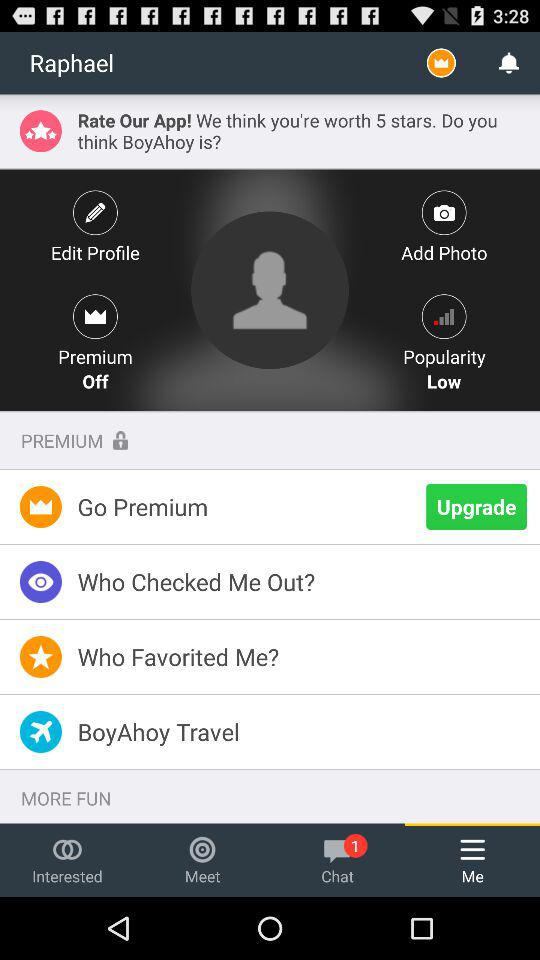What is the user name? The user name is Raphael. 